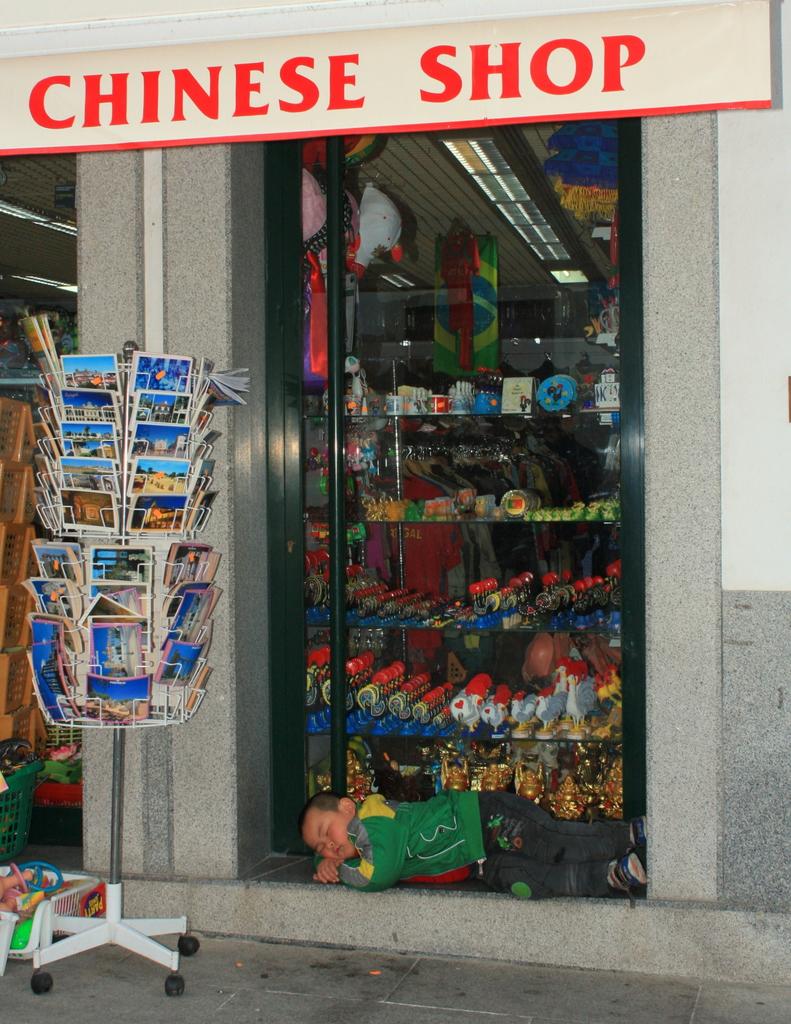What sort of shop is this?
Your answer should be very brief. Chinese. 